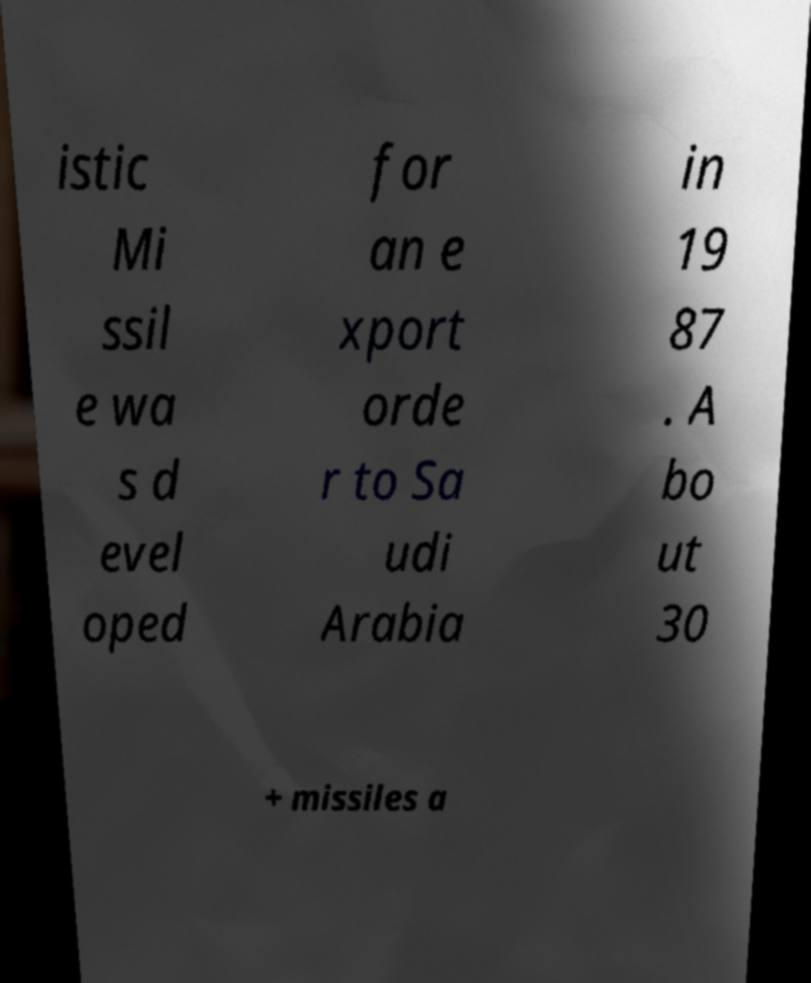Can you accurately transcribe the text from the provided image for me? istic Mi ssil e wa s d evel oped for an e xport orde r to Sa udi Arabia in 19 87 . A bo ut 30 + missiles a 